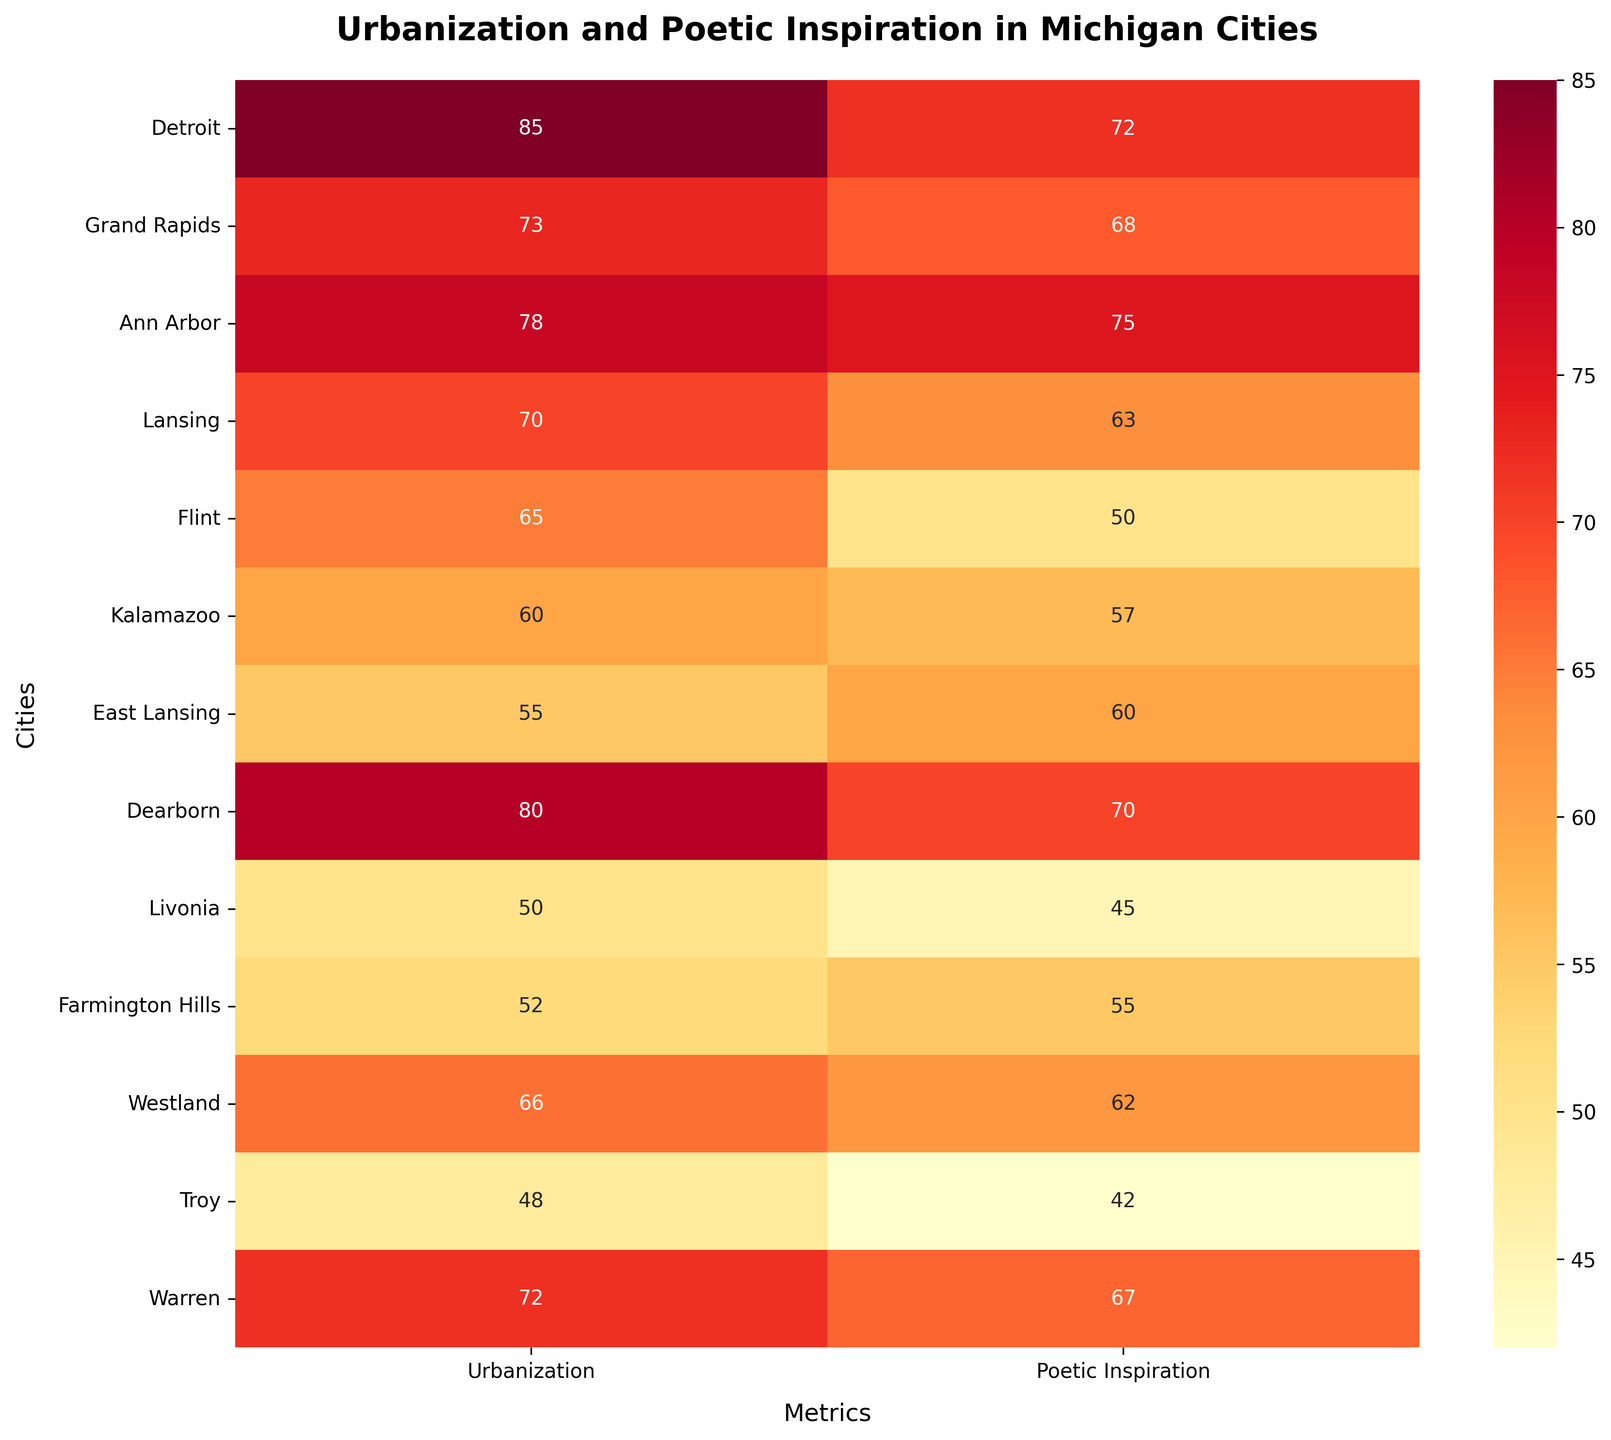What is the title of the heatmap? The title can be seen at the top of the figure and is prominently displayed to describe what the heatmap represents.
Answer: Urbanization and Poetic Inspiration in Michigan Cities How many cities are analyzed in the heatmap? The y-axis lists the cities analyzed in the figure, and each city name represents one data point. By counting the cities listed, we can find the total number.
Answer: 13 What is the Urbanization Level of Ann Arbor? Locate Ann Arbor on the y-axis, then read the Urbanization Level from the first column of its row.
Answer: 78 Which city has the highest Poetic Inspiration Score? Scan the Poetic Inspiration column and identify the city with the maximum value.
Answer: Ann Arbor Is the Poetic Inspiration Score for Detroit higher or lower than that for Grand Rapids? Compare the Poetic Inspiration Scores in the respective rows for Detroit and Grand Rapids. Detroit's value (72) is higher than Grand Rapids' value (68).
Answer: Higher Which city has a higher Urbanization Level, Lansing or Flint? Compare the Urbanization Levels in the respective rows for Lansing and Flint. Lansing has a value of 70, while Flint has a value of 65.
Answer: Lansing What is the average Poetic Inspiration Score of the cities in the heatmap? Add up all the Poetic Inspiration Scores and divide by the number of cities. (72 + 68 + 75 + 63 + 50 + 57 + 60 + 70 + 45 + 55 + 62 + 42 + 67) / 13 = 61
Answer: 61 Which city has the lowest Urbanization Level, and what is its corresponding Poetic Inspiration Score? Identify the row with the lowest Urbanization Level and then read the corresponding Poetic Inspiration Score from the same row. Troy has the lowest Urbanization Level of 48, and its Poetic Inspiration Score is 42.
Answer: Troy, 42 Is there a noticeable trend between Urbanization Level and Poetic Inspiration Score? By observing the heatmap, check if there appears to be a relationship between higher urbanization levels and higher poetic inspiration scores, and vice versa. Generally, higher Urbanization Levels seem to correlate with higher Poetic Inspiration Scores, indicating a positive trend.
Answer: Positive trend 